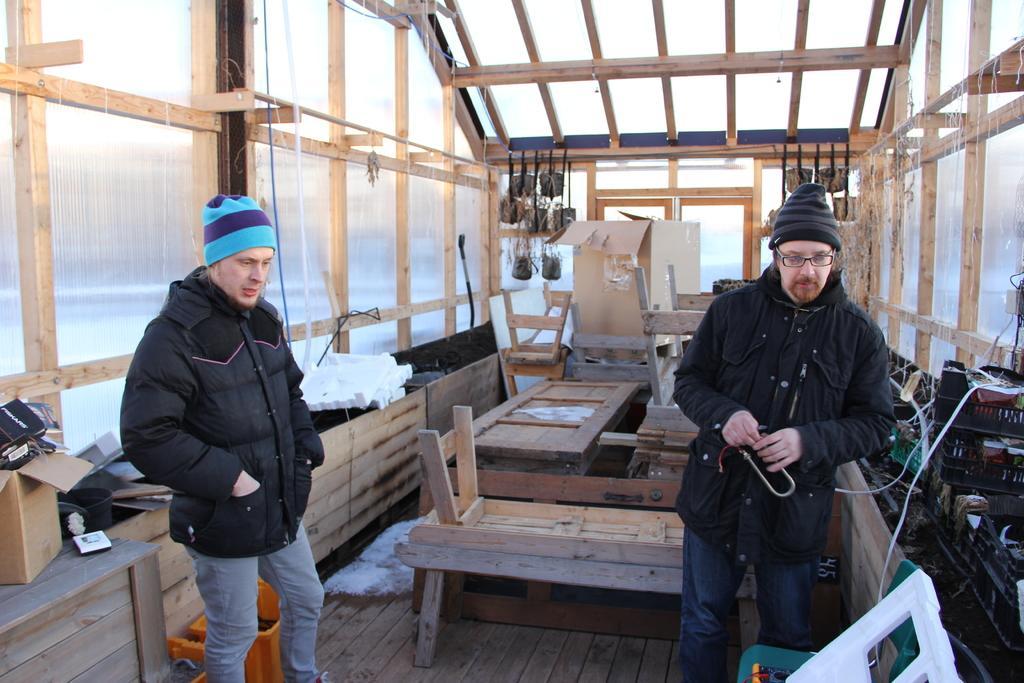Can you describe this image briefly? In this image I can see two men are standing and I can see both of them are wearing black colour jackets and caps. On the right side of this image I can see one man is wearing a specs. In the background I can see few tables, few stools, a box and few plants. On the both sides of the image I can see few containers, few boxes and few other stuffs. 